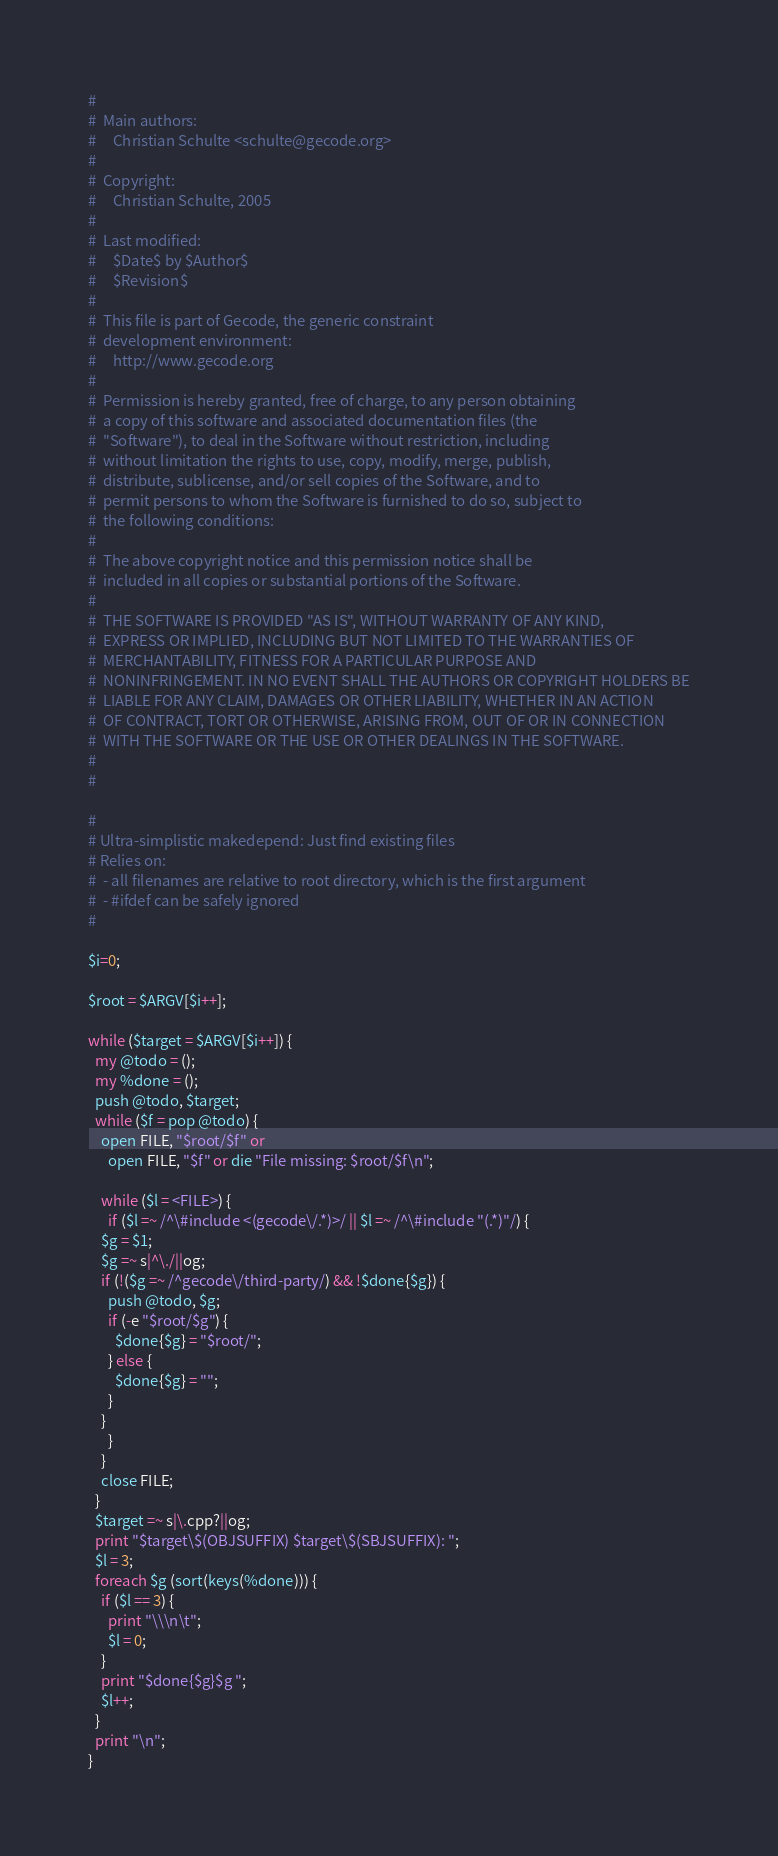Convert code to text. <code><loc_0><loc_0><loc_500><loc_500><_Perl_>#
#  Main authors:
#     Christian Schulte <schulte@gecode.org>
#
#  Copyright:
#     Christian Schulte, 2005
#
#  Last modified:
#     $Date$ by $Author$
#     $Revision$
#
#  This file is part of Gecode, the generic constraint
#  development environment:
#     http://www.gecode.org
#
#  Permission is hereby granted, free of charge, to any person obtaining
#  a copy of this software and associated documentation files (the
#  "Software"), to deal in the Software without restriction, including
#  without limitation the rights to use, copy, modify, merge, publish,
#  distribute, sublicense, and/or sell copies of the Software, and to
#  permit persons to whom the Software is furnished to do so, subject to
#  the following conditions:
#
#  The above copyright notice and this permission notice shall be
#  included in all copies or substantial portions of the Software.
#
#  THE SOFTWARE IS PROVIDED "AS IS", WITHOUT WARRANTY OF ANY KIND,
#  EXPRESS OR IMPLIED, INCLUDING BUT NOT LIMITED TO THE WARRANTIES OF
#  MERCHANTABILITY, FITNESS FOR A PARTICULAR PURPOSE AND
#  NONINFRINGEMENT. IN NO EVENT SHALL THE AUTHORS OR COPYRIGHT HOLDERS BE
#  LIABLE FOR ANY CLAIM, DAMAGES OR OTHER LIABILITY, WHETHER IN AN ACTION
#  OF CONTRACT, TORT OR OTHERWISE, ARISING FROM, OUT OF OR IN CONNECTION
#  WITH THE SOFTWARE OR THE USE OR OTHER DEALINGS IN THE SOFTWARE.
#
#

# 
# Ultra-simplistic makedepend: Just find existing files
# Relies on:
#  - all filenames are relative to root directory, which is the first argument
#  - #ifdef can be safely ignored
#

$i=0;

$root = $ARGV[$i++];

while ($target = $ARGV[$i++]) {
  my @todo = ();
  my %done = ();
  push @todo, $target;
  while ($f = pop @todo) {
    open FILE, "$root/$f" or
      open FILE, "$f" or die "File missing: $root/$f\n";
    
    while ($l = <FILE>) {
      if ($l =~ /^\#include <(gecode\/.*)>/ || $l =~ /^\#include "(.*)"/) {
	$g = $1;
	$g =~ s|^\./||og;
	if (!($g =~ /^gecode\/third-party/) && !$done{$g}) {
	  push @todo, $g;
	  if (-e "$root/$g") {
	    $done{$g} = "$root/";
	  } else {
	    $done{$g} = "";
	  }
	}
      }
    }
    close FILE;
  }
  $target =~ s|\.cpp?||og;
  print "$target\$(OBJSUFFIX) $target\$(SBJSUFFIX): ";
  $l = 3;
  foreach $g (sort(keys(%done))) {
    if ($l == 3) {
      print "\\\n\t";
      $l = 0;
    }
    print "$done{$g}$g ";
    $l++;
  }
  print "\n";
}

</code> 